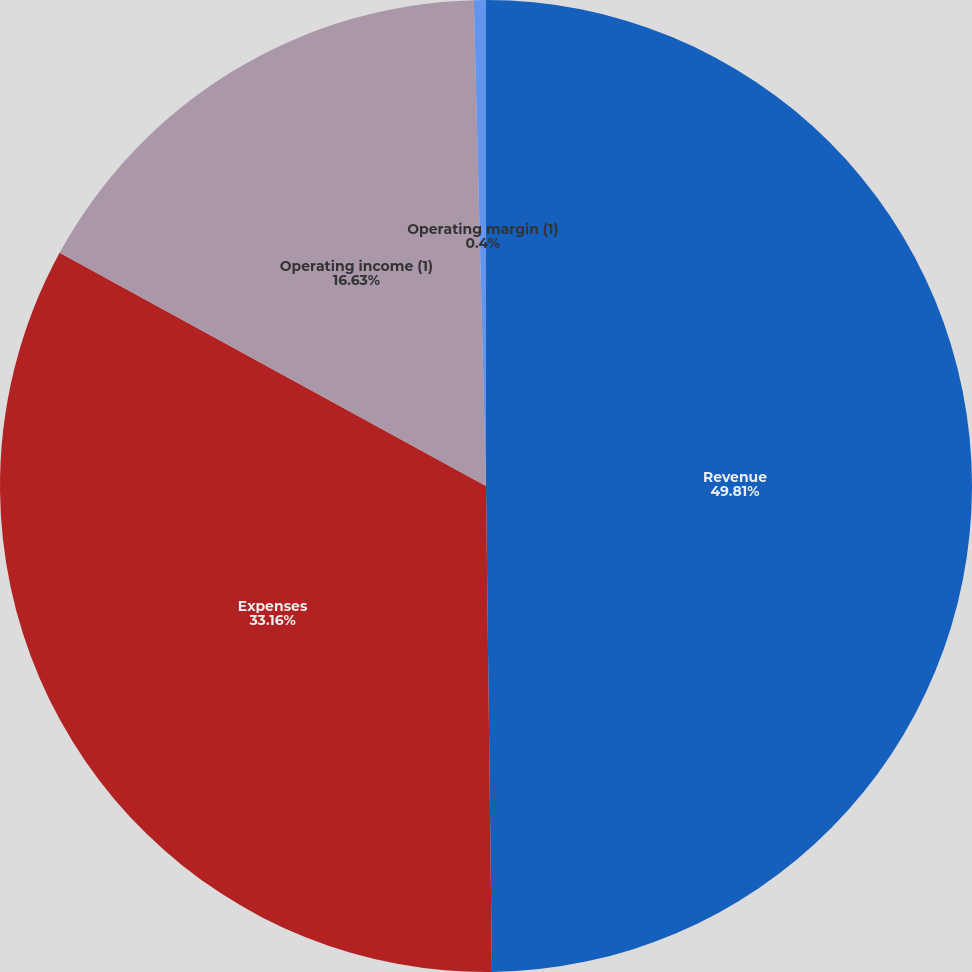Convert chart. <chart><loc_0><loc_0><loc_500><loc_500><pie_chart><fcel>Revenue<fcel>Expenses<fcel>Operating income (1)<fcel>Operating margin (1)<nl><fcel>49.8%<fcel>33.16%<fcel>16.63%<fcel>0.4%<nl></chart> 